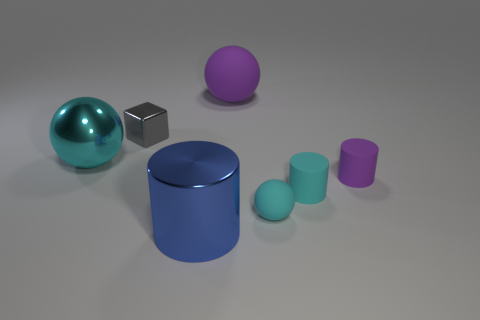Do the big thing that is in front of the metal ball and the gray cube have the same material?
Ensure brevity in your answer.  Yes. Is the number of things that are on the right side of the big matte thing less than the number of tiny gray metallic cubes?
Your answer should be very brief. No. There is a large metallic object that is in front of the large cyan object; what is its shape?
Give a very brief answer. Cylinder. What is the shape of the gray object that is the same size as the cyan cylinder?
Offer a very short reply. Cube. Is there another large cyan rubber object that has the same shape as the big rubber thing?
Provide a short and direct response. No. There is a purple rubber thing that is in front of the large purple ball; does it have the same shape as the big metal object behind the big blue cylinder?
Offer a terse response. No. There is a gray cube that is the same size as the purple cylinder; what is its material?
Provide a short and direct response. Metal. How many other things are there of the same material as the small sphere?
Your answer should be very brief. 3. The large metallic object that is behind the purple rubber thing in front of the large purple sphere is what shape?
Provide a short and direct response. Sphere. What number of objects are tiny purple objects or tiny rubber things to the left of the tiny cyan cylinder?
Your answer should be very brief. 2. 